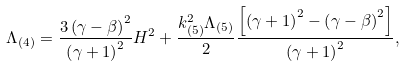Convert formula to latex. <formula><loc_0><loc_0><loc_500><loc_500>\Lambda _ { ( 4 ) } = \frac { 3 \left ( \gamma - \beta \right ) ^ { 2 } } { \left ( \gamma + 1 \right ) ^ { 2 } } H ^ { 2 } + \frac { k _ { ( 5 ) } ^ { 2 } \Lambda _ { ( 5 ) } } { 2 } \frac { \left [ \left ( \gamma + 1 \right ) ^ { 2 } - \left ( \gamma - \beta \right ) ^ { 2 } \right ] } { \left ( \gamma + 1 \right ) ^ { 2 } } ,</formula> 